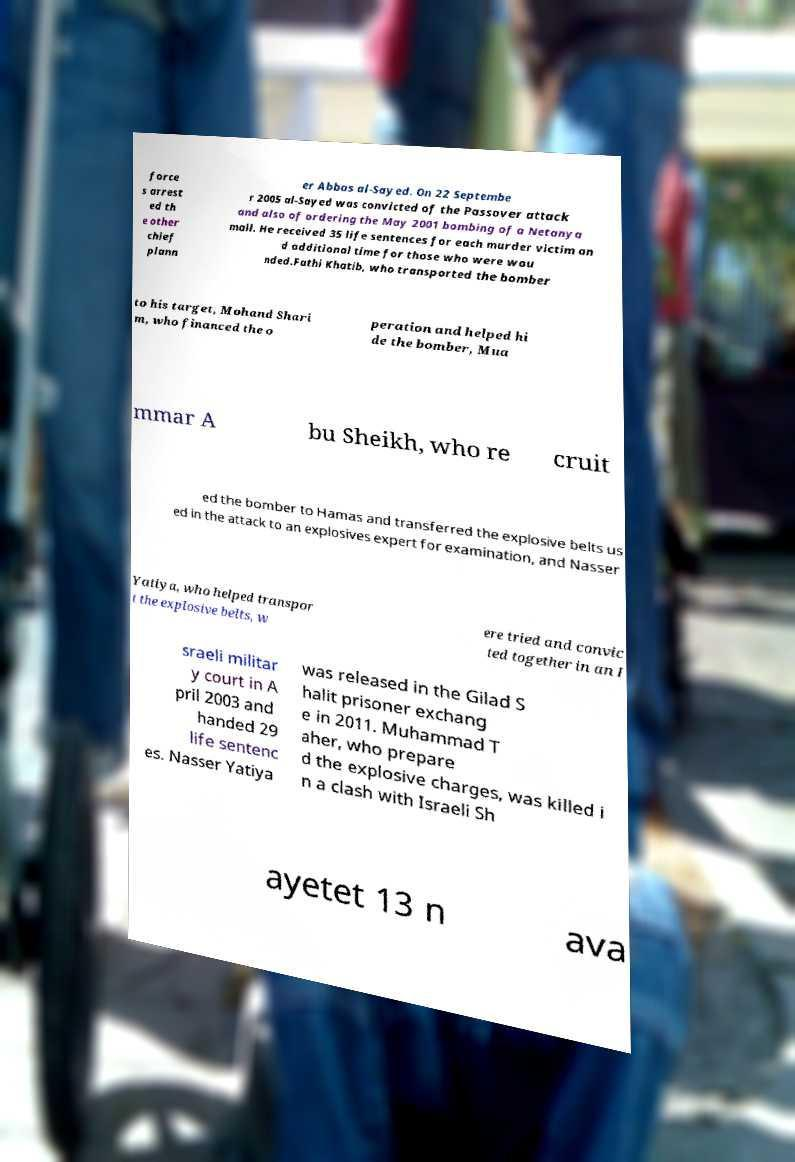There's text embedded in this image that I need extracted. Can you transcribe it verbatim? force s arrest ed th e other chief plann er Abbas al-Sayed. On 22 Septembe r 2005 al-Sayed was convicted of the Passover attack and also of ordering the May 2001 bombing of a Netanya mall. He received 35 life sentences for each murder victim an d additional time for those who were wou nded.Fathi Khatib, who transported the bomber to his target, Mohand Shari m, who financed the o peration and helped hi de the bomber, Mua mmar A bu Sheikh, who re cruit ed the bomber to Hamas and transferred the explosive belts us ed in the attack to an explosives expert for examination, and Nasser Yatiya, who helped transpor t the explosive belts, w ere tried and convic ted together in an I sraeli militar y court in A pril 2003 and handed 29 life sentenc es. Nasser Yatiya was released in the Gilad S halit prisoner exchang e in 2011. Muhammad T aher, who prepare d the explosive charges, was killed i n a clash with Israeli Sh ayetet 13 n ava 